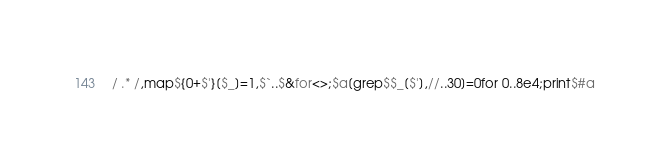<code> <loc_0><loc_0><loc_500><loc_500><_Perl_>/ .* /,map${0+$'}[$_]=1,$`..$&for<>;$a[grep$$_[$'],//..30]=0for 0..8e4;print$#a</code> 